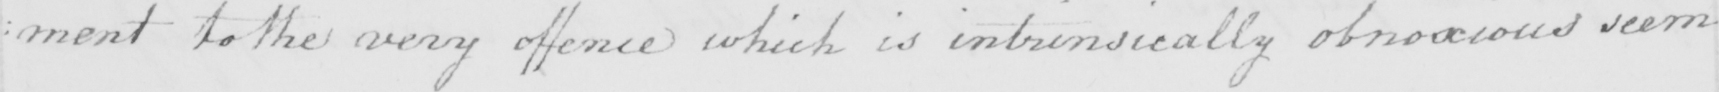Can you tell me what this handwritten text says? : ment to the very offence which is intrinsically obnoxious seem 